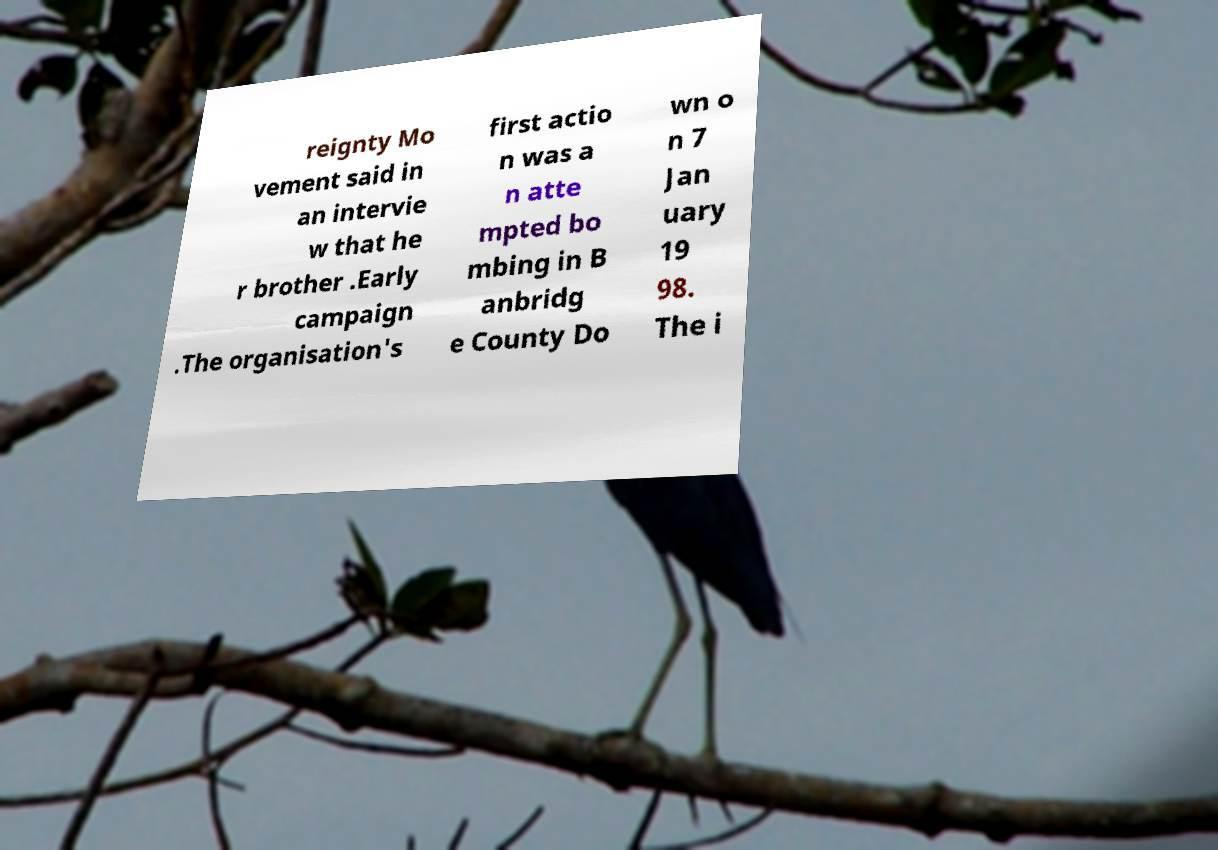Please identify and transcribe the text found in this image. reignty Mo vement said in an intervie w that he r brother .Early campaign .The organisation's first actio n was a n atte mpted bo mbing in B anbridg e County Do wn o n 7 Jan uary 19 98. The i 